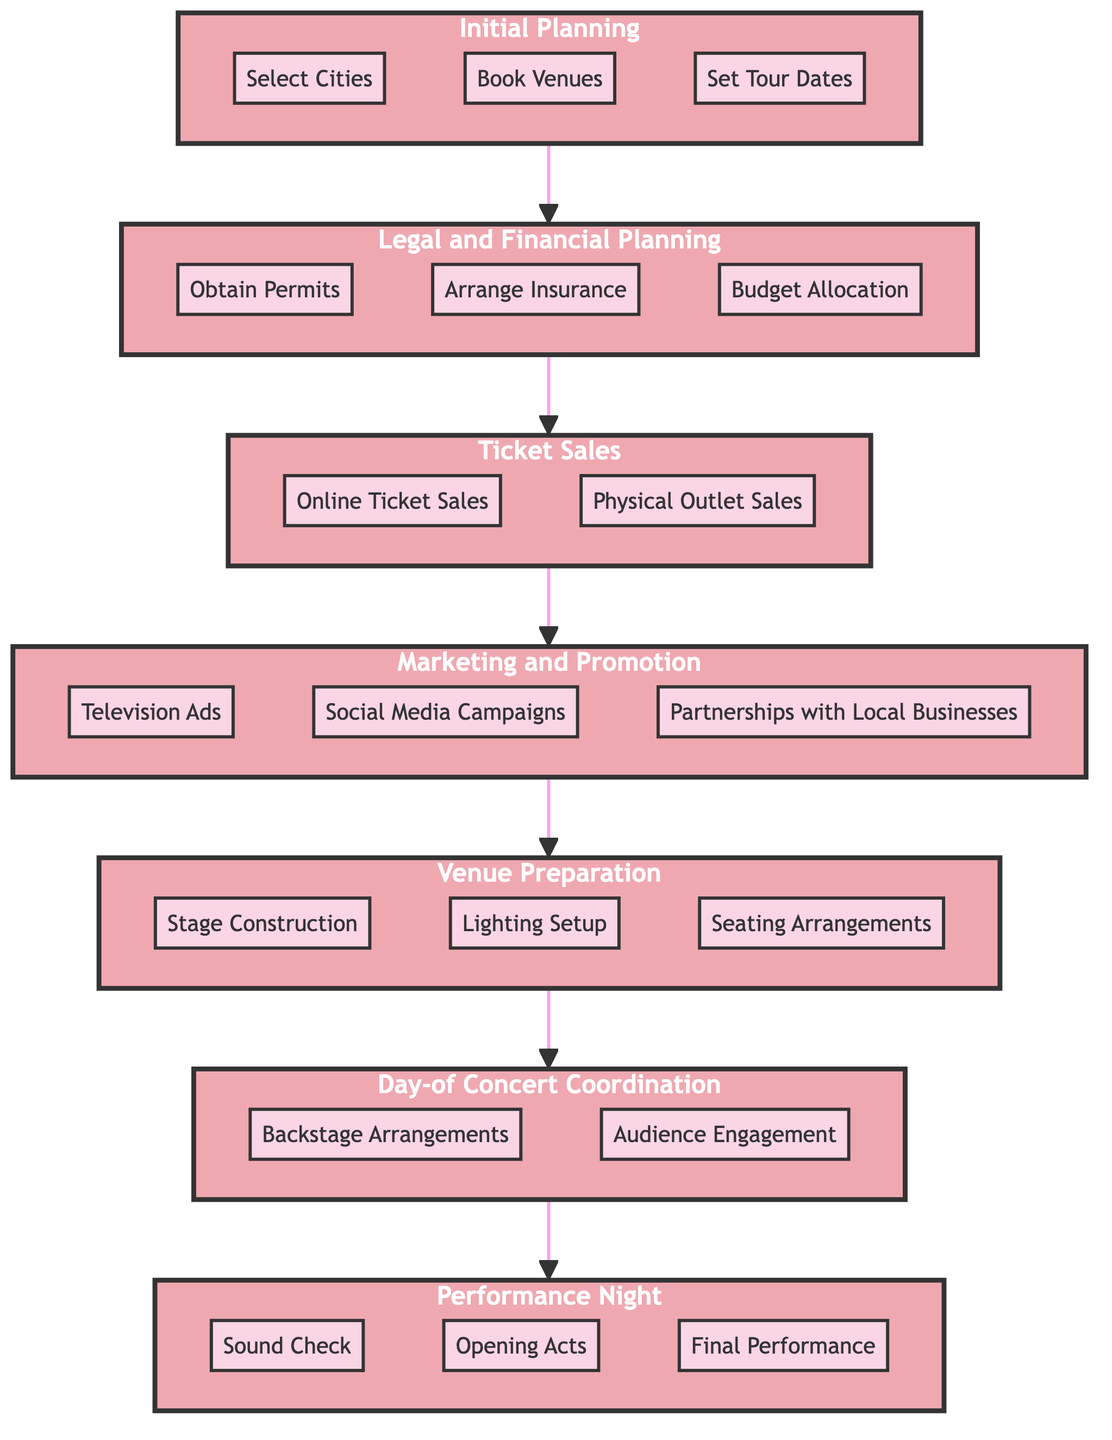What is the final stage of the concert tour process? The final stage in the flow chart is labeled "Performance Night," indicating it is the concluding part of the concert tour organization.
Answer: Performance Night How many tasks are involved in the Venue Preparation stage? The Venue Preparation stage consists of three tasks: Stage Construction, Lighting Setup, and Seating Arrangements. Thus, the total is three tasks.
Answer: Three What precedes Marketing and Promotion in the tour organization process? Marketing and Promotion follows Ticket Sales in the flow of the diagram, as indicated by the directed arrows connecting the stages.
Answer: Ticket Sales What is the first task listed under Legal and Financial Planning? The first task listed under the Legal and Financial Planning stage is "Obtain Permits." This follows the ordering provided in the diagram structure.
Answer: Obtain Permits What are the two tasks listed under Day-of Concert Coordination? The tasks include "Backstage Arrangements" and "Audience Engagement," which are specifically mentioned as the responsibilities for that stage.
Answer: Backstage Arrangements and Audience Engagement Which stage involves coordinating logistics on the day of the concert? The stage that handles logistics on the day of the concert is "Day-of Concert Coordination," focusing on everything that needs to happen right before the performance.
Answer: Day-of Concert Coordination Which tasks are necessary before setting up the concert venue? Before setting up the venue, one must first complete the tasks in the stages leading up to it: Initial Planning and Legal and Financial Planning. This logical progression is captured in the flow from the diagram.
Answer: Initial Planning and Legal and Financial Planning How many stages are outlined in the concert tour organizational chart? The organizational chart displays seven distinct stages, each representing a part of the tour planning process leading to the performance.
Answer: Seven 